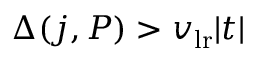Convert formula to latex. <formula><loc_0><loc_0><loc_500><loc_500>\Delta ( j , P ) > v _ { l r } | t |</formula> 